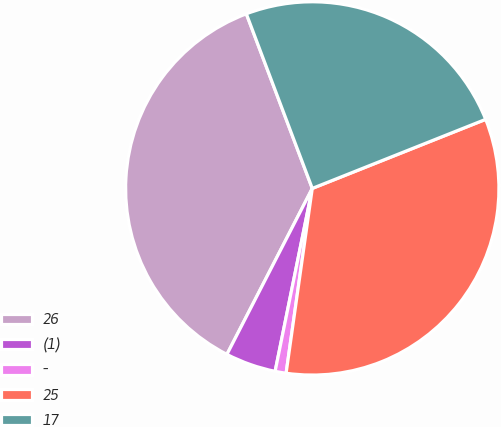Convert chart. <chart><loc_0><loc_0><loc_500><loc_500><pie_chart><fcel>26<fcel>(1)<fcel>-<fcel>25<fcel>17<nl><fcel>36.69%<fcel>4.37%<fcel>0.95%<fcel>33.27%<fcel>24.71%<nl></chart> 